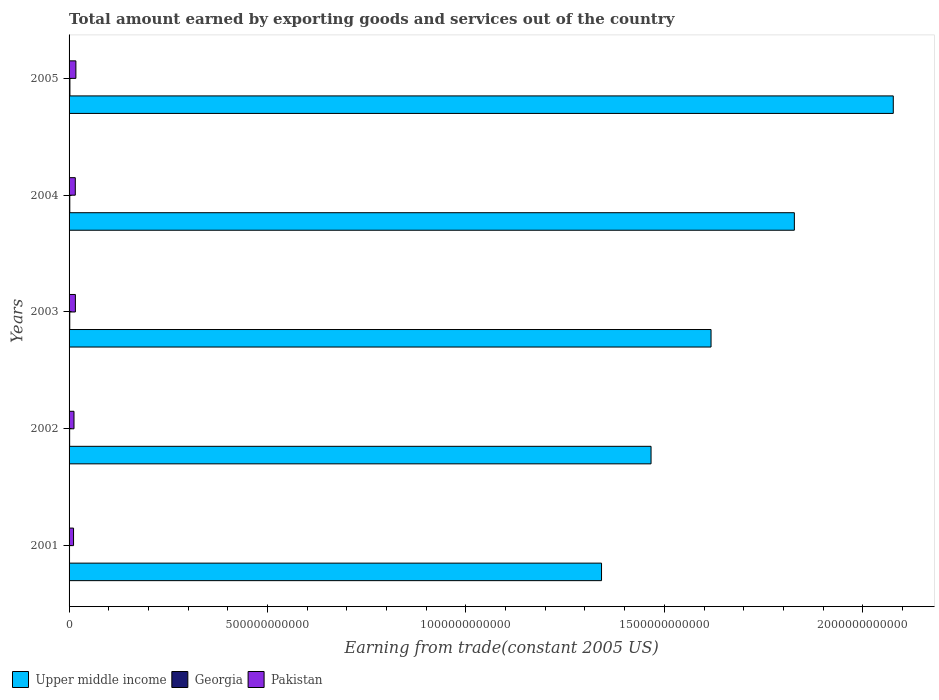How many different coloured bars are there?
Keep it short and to the point. 3. Are the number of bars on each tick of the Y-axis equal?
Provide a short and direct response. Yes. How many bars are there on the 1st tick from the bottom?
Offer a very short reply. 3. What is the label of the 3rd group of bars from the top?
Provide a short and direct response. 2003. In how many cases, is the number of bars for a given year not equal to the number of legend labels?
Ensure brevity in your answer.  0. What is the total amount earned by exporting goods and services in Georgia in 2005?
Offer a very short reply. 2.16e+09. Across all years, what is the maximum total amount earned by exporting goods and services in Upper middle income?
Offer a very short reply. 2.08e+12. Across all years, what is the minimum total amount earned by exporting goods and services in Georgia?
Your answer should be compact. 1.15e+09. In which year was the total amount earned by exporting goods and services in Upper middle income minimum?
Keep it short and to the point. 2001. What is the total total amount earned by exporting goods and services in Pakistan in the graph?
Keep it short and to the point. 7.25e+1. What is the difference between the total amount earned by exporting goods and services in Georgia in 2001 and that in 2004?
Your answer should be very brief. -6.92e+08. What is the difference between the total amount earned by exporting goods and services in Upper middle income in 2005 and the total amount earned by exporting goods and services in Georgia in 2003?
Keep it short and to the point. 2.08e+12. What is the average total amount earned by exporting goods and services in Pakistan per year?
Your answer should be very brief. 1.45e+1. In the year 2005, what is the difference between the total amount earned by exporting goods and services in Georgia and total amount earned by exporting goods and services in Upper middle income?
Keep it short and to the point. -2.07e+12. In how many years, is the total amount earned by exporting goods and services in Pakistan greater than 1600000000000 US$?
Make the answer very short. 0. What is the ratio of the total amount earned by exporting goods and services in Upper middle income in 2003 to that in 2004?
Make the answer very short. 0.89. Is the total amount earned by exporting goods and services in Upper middle income in 2002 less than that in 2004?
Your answer should be very brief. Yes. What is the difference between the highest and the second highest total amount earned by exporting goods and services in Pakistan?
Offer a very short reply. 1.26e+09. What is the difference between the highest and the lowest total amount earned by exporting goods and services in Upper middle income?
Your response must be concise. 7.35e+11. In how many years, is the total amount earned by exporting goods and services in Georgia greater than the average total amount earned by exporting goods and services in Georgia taken over all years?
Ensure brevity in your answer.  3. What does the 3rd bar from the top in 2001 represents?
Your answer should be very brief. Upper middle income. What does the 2nd bar from the bottom in 2002 represents?
Provide a short and direct response. Georgia. Is it the case that in every year, the sum of the total amount earned by exporting goods and services in Georgia and total amount earned by exporting goods and services in Upper middle income is greater than the total amount earned by exporting goods and services in Pakistan?
Provide a succinct answer. Yes. Are all the bars in the graph horizontal?
Offer a terse response. Yes. How many years are there in the graph?
Provide a short and direct response. 5. What is the difference between two consecutive major ticks on the X-axis?
Make the answer very short. 5.00e+11. Are the values on the major ticks of X-axis written in scientific E-notation?
Your response must be concise. No. Does the graph contain any zero values?
Keep it short and to the point. No. Does the graph contain grids?
Ensure brevity in your answer.  No. How are the legend labels stacked?
Your answer should be very brief. Horizontal. What is the title of the graph?
Provide a succinct answer. Total amount earned by exporting goods and services out of the country. Does "Angola" appear as one of the legend labels in the graph?
Ensure brevity in your answer.  No. What is the label or title of the X-axis?
Ensure brevity in your answer.  Earning from trade(constant 2005 US). What is the Earning from trade(constant 2005 US) of Upper middle income in 2001?
Provide a succinct answer. 1.34e+12. What is the Earning from trade(constant 2005 US) in Georgia in 2001?
Your answer should be compact. 1.15e+09. What is the Earning from trade(constant 2005 US) in Pakistan in 2001?
Your answer should be very brief. 1.13e+1. What is the Earning from trade(constant 2005 US) in Upper middle income in 2002?
Make the answer very short. 1.47e+12. What is the Earning from trade(constant 2005 US) of Georgia in 2002?
Provide a short and direct response. 1.45e+09. What is the Earning from trade(constant 2005 US) of Pakistan in 2002?
Offer a very short reply. 1.24e+1. What is the Earning from trade(constant 2005 US) in Upper middle income in 2003?
Provide a succinct answer. 1.62e+12. What is the Earning from trade(constant 2005 US) in Georgia in 2003?
Give a very brief answer. 1.76e+09. What is the Earning from trade(constant 2005 US) of Pakistan in 2003?
Ensure brevity in your answer.  1.59e+1. What is the Earning from trade(constant 2005 US) in Upper middle income in 2004?
Your answer should be compact. 1.83e+12. What is the Earning from trade(constant 2005 US) in Georgia in 2004?
Your answer should be compact. 1.85e+09. What is the Earning from trade(constant 2005 US) of Pakistan in 2004?
Offer a terse response. 1.57e+1. What is the Earning from trade(constant 2005 US) of Upper middle income in 2005?
Make the answer very short. 2.08e+12. What is the Earning from trade(constant 2005 US) of Georgia in 2005?
Make the answer very short. 2.16e+09. What is the Earning from trade(constant 2005 US) in Pakistan in 2005?
Your answer should be compact. 1.72e+1. Across all years, what is the maximum Earning from trade(constant 2005 US) in Upper middle income?
Ensure brevity in your answer.  2.08e+12. Across all years, what is the maximum Earning from trade(constant 2005 US) of Georgia?
Ensure brevity in your answer.  2.16e+09. Across all years, what is the maximum Earning from trade(constant 2005 US) in Pakistan?
Provide a short and direct response. 1.72e+1. Across all years, what is the minimum Earning from trade(constant 2005 US) of Upper middle income?
Ensure brevity in your answer.  1.34e+12. Across all years, what is the minimum Earning from trade(constant 2005 US) in Georgia?
Provide a short and direct response. 1.15e+09. Across all years, what is the minimum Earning from trade(constant 2005 US) in Pakistan?
Your answer should be very brief. 1.13e+1. What is the total Earning from trade(constant 2005 US) of Upper middle income in the graph?
Give a very brief answer. 8.33e+12. What is the total Earning from trade(constant 2005 US) of Georgia in the graph?
Offer a very short reply. 8.38e+09. What is the total Earning from trade(constant 2005 US) in Pakistan in the graph?
Make the answer very short. 7.25e+1. What is the difference between the Earning from trade(constant 2005 US) in Upper middle income in 2001 and that in 2002?
Keep it short and to the point. -1.25e+11. What is the difference between the Earning from trade(constant 2005 US) of Georgia in 2001 and that in 2002?
Your answer should be very brief. -3.00e+08. What is the difference between the Earning from trade(constant 2005 US) of Pakistan in 2001 and that in 2002?
Your answer should be compact. -1.12e+09. What is the difference between the Earning from trade(constant 2005 US) of Upper middle income in 2001 and that in 2003?
Give a very brief answer. -2.76e+11. What is the difference between the Earning from trade(constant 2005 US) in Georgia in 2001 and that in 2003?
Make the answer very short. -6.05e+08. What is the difference between the Earning from trade(constant 2005 US) in Pakistan in 2001 and that in 2003?
Ensure brevity in your answer.  -4.64e+09. What is the difference between the Earning from trade(constant 2005 US) in Upper middle income in 2001 and that in 2004?
Your answer should be compact. -4.86e+11. What is the difference between the Earning from trade(constant 2005 US) in Georgia in 2001 and that in 2004?
Keep it short and to the point. -6.92e+08. What is the difference between the Earning from trade(constant 2005 US) in Pakistan in 2001 and that in 2004?
Keep it short and to the point. -4.40e+09. What is the difference between the Earning from trade(constant 2005 US) in Upper middle income in 2001 and that in 2005?
Provide a succinct answer. -7.35e+11. What is the difference between the Earning from trade(constant 2005 US) of Georgia in 2001 and that in 2005?
Offer a terse response. -1.01e+09. What is the difference between the Earning from trade(constant 2005 US) in Pakistan in 2001 and that in 2005?
Offer a very short reply. -5.90e+09. What is the difference between the Earning from trade(constant 2005 US) in Upper middle income in 2002 and that in 2003?
Offer a terse response. -1.51e+11. What is the difference between the Earning from trade(constant 2005 US) in Georgia in 2002 and that in 2003?
Ensure brevity in your answer.  -3.05e+08. What is the difference between the Earning from trade(constant 2005 US) in Pakistan in 2002 and that in 2003?
Your response must be concise. -3.52e+09. What is the difference between the Earning from trade(constant 2005 US) in Upper middle income in 2002 and that in 2004?
Your response must be concise. -3.61e+11. What is the difference between the Earning from trade(constant 2005 US) in Georgia in 2002 and that in 2004?
Provide a short and direct response. -3.92e+08. What is the difference between the Earning from trade(constant 2005 US) of Pakistan in 2002 and that in 2004?
Your answer should be compact. -3.28e+09. What is the difference between the Earning from trade(constant 2005 US) in Upper middle income in 2002 and that in 2005?
Provide a short and direct response. -6.10e+11. What is the difference between the Earning from trade(constant 2005 US) in Georgia in 2002 and that in 2005?
Provide a succinct answer. -7.09e+08. What is the difference between the Earning from trade(constant 2005 US) of Pakistan in 2002 and that in 2005?
Give a very brief answer. -4.78e+09. What is the difference between the Earning from trade(constant 2005 US) of Upper middle income in 2003 and that in 2004?
Provide a succinct answer. -2.10e+11. What is the difference between the Earning from trade(constant 2005 US) of Georgia in 2003 and that in 2004?
Provide a succinct answer. -8.66e+07. What is the difference between the Earning from trade(constant 2005 US) of Pakistan in 2003 and that in 2004?
Offer a terse response. 2.43e+08. What is the difference between the Earning from trade(constant 2005 US) of Upper middle income in 2003 and that in 2005?
Give a very brief answer. -4.59e+11. What is the difference between the Earning from trade(constant 2005 US) of Georgia in 2003 and that in 2005?
Provide a short and direct response. -4.04e+08. What is the difference between the Earning from trade(constant 2005 US) in Pakistan in 2003 and that in 2005?
Offer a terse response. -1.26e+09. What is the difference between the Earning from trade(constant 2005 US) of Upper middle income in 2004 and that in 2005?
Your response must be concise. -2.49e+11. What is the difference between the Earning from trade(constant 2005 US) in Georgia in 2004 and that in 2005?
Provide a succinct answer. -3.18e+08. What is the difference between the Earning from trade(constant 2005 US) in Pakistan in 2004 and that in 2005?
Offer a very short reply. -1.50e+09. What is the difference between the Earning from trade(constant 2005 US) in Upper middle income in 2001 and the Earning from trade(constant 2005 US) in Georgia in 2002?
Make the answer very short. 1.34e+12. What is the difference between the Earning from trade(constant 2005 US) of Upper middle income in 2001 and the Earning from trade(constant 2005 US) of Pakistan in 2002?
Ensure brevity in your answer.  1.33e+12. What is the difference between the Earning from trade(constant 2005 US) in Georgia in 2001 and the Earning from trade(constant 2005 US) in Pakistan in 2002?
Ensure brevity in your answer.  -1.12e+1. What is the difference between the Earning from trade(constant 2005 US) in Upper middle income in 2001 and the Earning from trade(constant 2005 US) in Georgia in 2003?
Your response must be concise. 1.34e+12. What is the difference between the Earning from trade(constant 2005 US) of Upper middle income in 2001 and the Earning from trade(constant 2005 US) of Pakistan in 2003?
Keep it short and to the point. 1.33e+12. What is the difference between the Earning from trade(constant 2005 US) in Georgia in 2001 and the Earning from trade(constant 2005 US) in Pakistan in 2003?
Your answer should be very brief. -1.48e+1. What is the difference between the Earning from trade(constant 2005 US) of Upper middle income in 2001 and the Earning from trade(constant 2005 US) of Georgia in 2004?
Your answer should be very brief. 1.34e+12. What is the difference between the Earning from trade(constant 2005 US) in Upper middle income in 2001 and the Earning from trade(constant 2005 US) in Pakistan in 2004?
Offer a very short reply. 1.33e+12. What is the difference between the Earning from trade(constant 2005 US) in Georgia in 2001 and the Earning from trade(constant 2005 US) in Pakistan in 2004?
Make the answer very short. -1.45e+1. What is the difference between the Earning from trade(constant 2005 US) of Upper middle income in 2001 and the Earning from trade(constant 2005 US) of Georgia in 2005?
Offer a very short reply. 1.34e+12. What is the difference between the Earning from trade(constant 2005 US) in Upper middle income in 2001 and the Earning from trade(constant 2005 US) in Pakistan in 2005?
Give a very brief answer. 1.32e+12. What is the difference between the Earning from trade(constant 2005 US) in Georgia in 2001 and the Earning from trade(constant 2005 US) in Pakistan in 2005?
Your response must be concise. -1.60e+1. What is the difference between the Earning from trade(constant 2005 US) in Upper middle income in 2002 and the Earning from trade(constant 2005 US) in Georgia in 2003?
Your answer should be compact. 1.46e+12. What is the difference between the Earning from trade(constant 2005 US) in Upper middle income in 2002 and the Earning from trade(constant 2005 US) in Pakistan in 2003?
Give a very brief answer. 1.45e+12. What is the difference between the Earning from trade(constant 2005 US) in Georgia in 2002 and the Earning from trade(constant 2005 US) in Pakistan in 2003?
Your answer should be compact. -1.45e+1. What is the difference between the Earning from trade(constant 2005 US) of Upper middle income in 2002 and the Earning from trade(constant 2005 US) of Georgia in 2004?
Offer a very short reply. 1.46e+12. What is the difference between the Earning from trade(constant 2005 US) of Upper middle income in 2002 and the Earning from trade(constant 2005 US) of Pakistan in 2004?
Offer a terse response. 1.45e+12. What is the difference between the Earning from trade(constant 2005 US) of Georgia in 2002 and the Earning from trade(constant 2005 US) of Pakistan in 2004?
Your answer should be very brief. -1.42e+1. What is the difference between the Earning from trade(constant 2005 US) of Upper middle income in 2002 and the Earning from trade(constant 2005 US) of Georgia in 2005?
Ensure brevity in your answer.  1.46e+12. What is the difference between the Earning from trade(constant 2005 US) of Upper middle income in 2002 and the Earning from trade(constant 2005 US) of Pakistan in 2005?
Your answer should be compact. 1.45e+12. What is the difference between the Earning from trade(constant 2005 US) of Georgia in 2002 and the Earning from trade(constant 2005 US) of Pakistan in 2005?
Offer a terse response. -1.57e+1. What is the difference between the Earning from trade(constant 2005 US) of Upper middle income in 2003 and the Earning from trade(constant 2005 US) of Georgia in 2004?
Provide a short and direct response. 1.62e+12. What is the difference between the Earning from trade(constant 2005 US) in Upper middle income in 2003 and the Earning from trade(constant 2005 US) in Pakistan in 2004?
Provide a short and direct response. 1.60e+12. What is the difference between the Earning from trade(constant 2005 US) in Georgia in 2003 and the Earning from trade(constant 2005 US) in Pakistan in 2004?
Provide a succinct answer. -1.39e+1. What is the difference between the Earning from trade(constant 2005 US) in Upper middle income in 2003 and the Earning from trade(constant 2005 US) in Georgia in 2005?
Offer a terse response. 1.62e+12. What is the difference between the Earning from trade(constant 2005 US) of Upper middle income in 2003 and the Earning from trade(constant 2005 US) of Pakistan in 2005?
Keep it short and to the point. 1.60e+12. What is the difference between the Earning from trade(constant 2005 US) in Georgia in 2003 and the Earning from trade(constant 2005 US) in Pakistan in 2005?
Give a very brief answer. -1.54e+1. What is the difference between the Earning from trade(constant 2005 US) of Upper middle income in 2004 and the Earning from trade(constant 2005 US) of Georgia in 2005?
Provide a succinct answer. 1.83e+12. What is the difference between the Earning from trade(constant 2005 US) of Upper middle income in 2004 and the Earning from trade(constant 2005 US) of Pakistan in 2005?
Your response must be concise. 1.81e+12. What is the difference between the Earning from trade(constant 2005 US) of Georgia in 2004 and the Earning from trade(constant 2005 US) of Pakistan in 2005?
Provide a succinct answer. -1.53e+1. What is the average Earning from trade(constant 2005 US) in Upper middle income per year?
Give a very brief answer. 1.67e+12. What is the average Earning from trade(constant 2005 US) of Georgia per year?
Keep it short and to the point. 1.68e+09. What is the average Earning from trade(constant 2005 US) in Pakistan per year?
Make the answer very short. 1.45e+1. In the year 2001, what is the difference between the Earning from trade(constant 2005 US) in Upper middle income and Earning from trade(constant 2005 US) in Georgia?
Make the answer very short. 1.34e+12. In the year 2001, what is the difference between the Earning from trade(constant 2005 US) in Upper middle income and Earning from trade(constant 2005 US) in Pakistan?
Ensure brevity in your answer.  1.33e+12. In the year 2001, what is the difference between the Earning from trade(constant 2005 US) of Georgia and Earning from trade(constant 2005 US) of Pakistan?
Provide a short and direct response. -1.01e+1. In the year 2002, what is the difference between the Earning from trade(constant 2005 US) in Upper middle income and Earning from trade(constant 2005 US) in Georgia?
Your answer should be very brief. 1.47e+12. In the year 2002, what is the difference between the Earning from trade(constant 2005 US) in Upper middle income and Earning from trade(constant 2005 US) in Pakistan?
Your response must be concise. 1.45e+12. In the year 2002, what is the difference between the Earning from trade(constant 2005 US) in Georgia and Earning from trade(constant 2005 US) in Pakistan?
Provide a succinct answer. -1.09e+1. In the year 2003, what is the difference between the Earning from trade(constant 2005 US) in Upper middle income and Earning from trade(constant 2005 US) in Georgia?
Make the answer very short. 1.62e+12. In the year 2003, what is the difference between the Earning from trade(constant 2005 US) of Upper middle income and Earning from trade(constant 2005 US) of Pakistan?
Your response must be concise. 1.60e+12. In the year 2003, what is the difference between the Earning from trade(constant 2005 US) of Georgia and Earning from trade(constant 2005 US) of Pakistan?
Ensure brevity in your answer.  -1.42e+1. In the year 2004, what is the difference between the Earning from trade(constant 2005 US) of Upper middle income and Earning from trade(constant 2005 US) of Georgia?
Offer a very short reply. 1.83e+12. In the year 2004, what is the difference between the Earning from trade(constant 2005 US) in Upper middle income and Earning from trade(constant 2005 US) in Pakistan?
Provide a short and direct response. 1.81e+12. In the year 2004, what is the difference between the Earning from trade(constant 2005 US) of Georgia and Earning from trade(constant 2005 US) of Pakistan?
Offer a very short reply. -1.38e+1. In the year 2005, what is the difference between the Earning from trade(constant 2005 US) in Upper middle income and Earning from trade(constant 2005 US) in Georgia?
Provide a succinct answer. 2.07e+12. In the year 2005, what is the difference between the Earning from trade(constant 2005 US) of Upper middle income and Earning from trade(constant 2005 US) of Pakistan?
Provide a succinct answer. 2.06e+12. In the year 2005, what is the difference between the Earning from trade(constant 2005 US) of Georgia and Earning from trade(constant 2005 US) of Pakistan?
Your answer should be compact. -1.50e+1. What is the ratio of the Earning from trade(constant 2005 US) in Upper middle income in 2001 to that in 2002?
Provide a short and direct response. 0.91. What is the ratio of the Earning from trade(constant 2005 US) of Georgia in 2001 to that in 2002?
Your answer should be very brief. 0.79. What is the ratio of the Earning from trade(constant 2005 US) of Pakistan in 2001 to that in 2002?
Keep it short and to the point. 0.91. What is the ratio of the Earning from trade(constant 2005 US) of Upper middle income in 2001 to that in 2003?
Provide a short and direct response. 0.83. What is the ratio of the Earning from trade(constant 2005 US) of Georgia in 2001 to that in 2003?
Give a very brief answer. 0.66. What is the ratio of the Earning from trade(constant 2005 US) of Pakistan in 2001 to that in 2003?
Your response must be concise. 0.71. What is the ratio of the Earning from trade(constant 2005 US) in Upper middle income in 2001 to that in 2004?
Offer a very short reply. 0.73. What is the ratio of the Earning from trade(constant 2005 US) in Georgia in 2001 to that in 2004?
Your answer should be compact. 0.63. What is the ratio of the Earning from trade(constant 2005 US) in Pakistan in 2001 to that in 2004?
Give a very brief answer. 0.72. What is the ratio of the Earning from trade(constant 2005 US) of Upper middle income in 2001 to that in 2005?
Make the answer very short. 0.65. What is the ratio of the Earning from trade(constant 2005 US) in Georgia in 2001 to that in 2005?
Your response must be concise. 0.53. What is the ratio of the Earning from trade(constant 2005 US) of Pakistan in 2001 to that in 2005?
Provide a short and direct response. 0.66. What is the ratio of the Earning from trade(constant 2005 US) of Upper middle income in 2002 to that in 2003?
Give a very brief answer. 0.91. What is the ratio of the Earning from trade(constant 2005 US) of Georgia in 2002 to that in 2003?
Offer a terse response. 0.83. What is the ratio of the Earning from trade(constant 2005 US) in Pakistan in 2002 to that in 2003?
Make the answer very short. 0.78. What is the ratio of the Earning from trade(constant 2005 US) in Upper middle income in 2002 to that in 2004?
Offer a very short reply. 0.8. What is the ratio of the Earning from trade(constant 2005 US) of Georgia in 2002 to that in 2004?
Your answer should be very brief. 0.79. What is the ratio of the Earning from trade(constant 2005 US) in Pakistan in 2002 to that in 2004?
Your answer should be compact. 0.79. What is the ratio of the Earning from trade(constant 2005 US) of Upper middle income in 2002 to that in 2005?
Offer a very short reply. 0.71. What is the ratio of the Earning from trade(constant 2005 US) of Georgia in 2002 to that in 2005?
Ensure brevity in your answer.  0.67. What is the ratio of the Earning from trade(constant 2005 US) of Pakistan in 2002 to that in 2005?
Provide a short and direct response. 0.72. What is the ratio of the Earning from trade(constant 2005 US) in Upper middle income in 2003 to that in 2004?
Your response must be concise. 0.89. What is the ratio of the Earning from trade(constant 2005 US) in Georgia in 2003 to that in 2004?
Your response must be concise. 0.95. What is the ratio of the Earning from trade(constant 2005 US) of Pakistan in 2003 to that in 2004?
Provide a short and direct response. 1.02. What is the ratio of the Earning from trade(constant 2005 US) in Upper middle income in 2003 to that in 2005?
Make the answer very short. 0.78. What is the ratio of the Earning from trade(constant 2005 US) of Georgia in 2003 to that in 2005?
Your answer should be compact. 0.81. What is the ratio of the Earning from trade(constant 2005 US) of Pakistan in 2003 to that in 2005?
Provide a short and direct response. 0.93. What is the ratio of the Earning from trade(constant 2005 US) of Upper middle income in 2004 to that in 2005?
Provide a succinct answer. 0.88. What is the ratio of the Earning from trade(constant 2005 US) of Georgia in 2004 to that in 2005?
Give a very brief answer. 0.85. What is the ratio of the Earning from trade(constant 2005 US) in Pakistan in 2004 to that in 2005?
Your response must be concise. 0.91. What is the difference between the highest and the second highest Earning from trade(constant 2005 US) of Upper middle income?
Make the answer very short. 2.49e+11. What is the difference between the highest and the second highest Earning from trade(constant 2005 US) in Georgia?
Give a very brief answer. 3.18e+08. What is the difference between the highest and the second highest Earning from trade(constant 2005 US) in Pakistan?
Give a very brief answer. 1.26e+09. What is the difference between the highest and the lowest Earning from trade(constant 2005 US) in Upper middle income?
Your response must be concise. 7.35e+11. What is the difference between the highest and the lowest Earning from trade(constant 2005 US) in Georgia?
Offer a terse response. 1.01e+09. What is the difference between the highest and the lowest Earning from trade(constant 2005 US) of Pakistan?
Provide a short and direct response. 5.90e+09. 